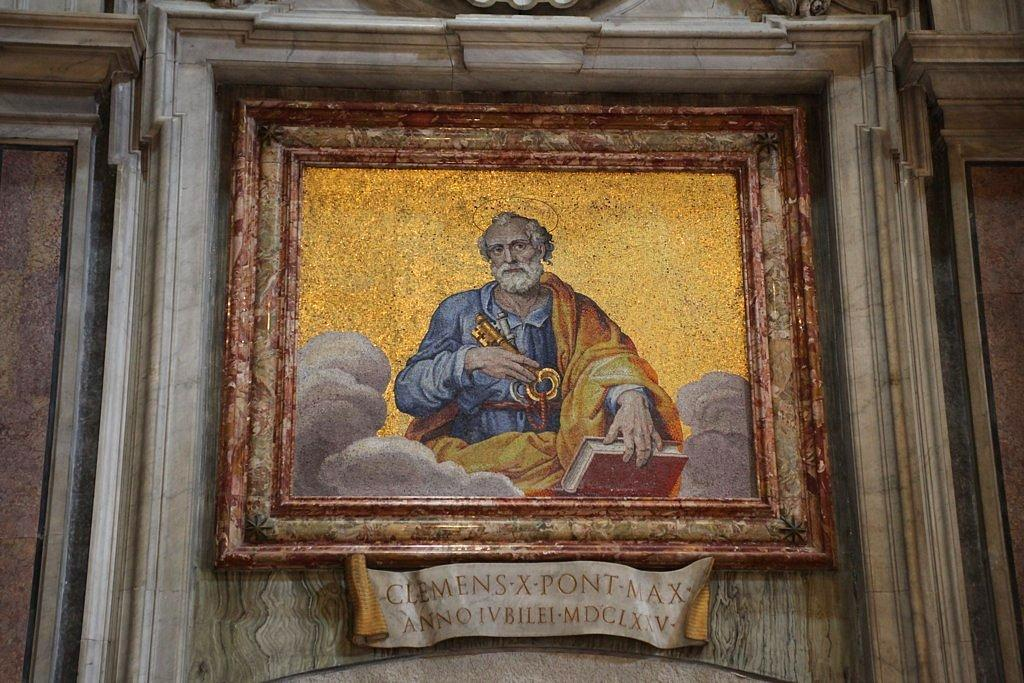What object can be seen in the image? There is a photo frame in the image. Where is the photo frame located? The photo frame is on a wall. What is the size of the wealth in the image? There is no mention of wealth in the image, as it only features a photo frame on a wall. 